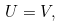Convert formula to latex. <formula><loc_0><loc_0><loc_500><loc_500>U = V ,</formula> 